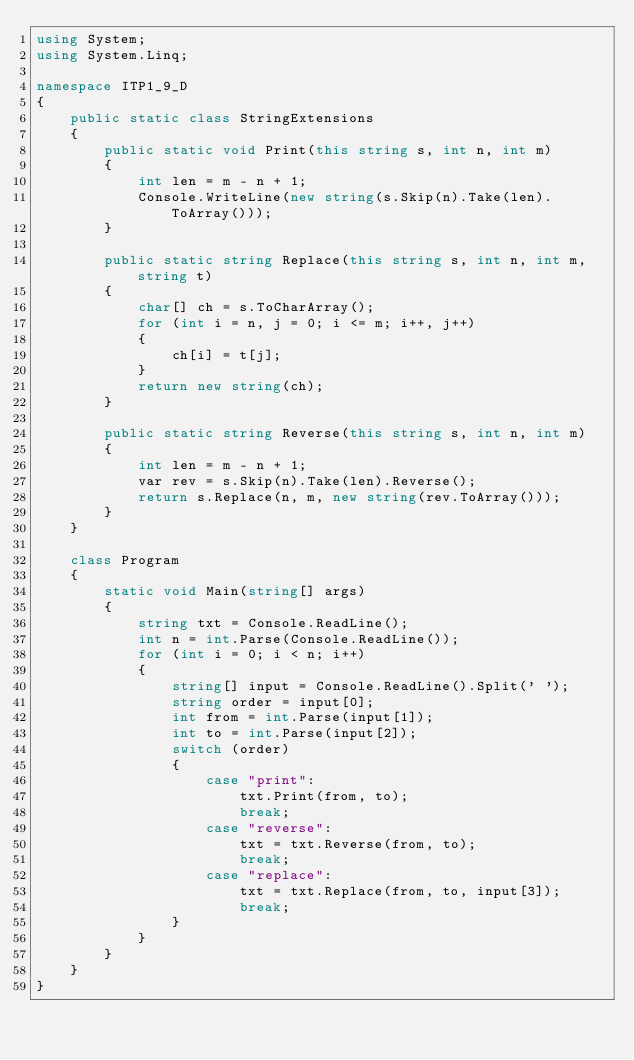<code> <loc_0><loc_0><loc_500><loc_500><_C#_>using System;
using System.Linq;

namespace ITP1_9_D
{
    public static class StringExtensions
    {
        public static void Print(this string s, int n, int m)
        {
            int len = m - n + 1;
            Console.WriteLine(new string(s.Skip(n).Take(len).ToArray()));
        }

        public static string Replace(this string s, int n, int m, string t)
        {
            char[] ch = s.ToCharArray();
            for (int i = n, j = 0; i <= m; i++, j++)
            {
                ch[i] = t[j];
            }
            return new string(ch);
        }

        public static string Reverse(this string s, int n, int m)
        {
            int len = m - n + 1;
            var rev = s.Skip(n).Take(len).Reverse();
            return s.Replace(n, m, new string(rev.ToArray()));
        }
    }

    class Program
    {
        static void Main(string[] args)
        {
            string txt = Console.ReadLine();
            int n = int.Parse(Console.ReadLine());
            for (int i = 0; i < n; i++)
            {
                string[] input = Console.ReadLine().Split(' ');
                string order = input[0];
                int from = int.Parse(input[1]);
                int to = int.Parse(input[2]);
                switch (order)
                {
                    case "print":
                        txt.Print(from, to);
                        break;
                    case "reverse":
                        txt = txt.Reverse(from, to);
                        break;
                    case "replace":
                        txt = txt.Replace(from, to, input[3]);
                        break;
                }
            }
        }
    }
}</code> 